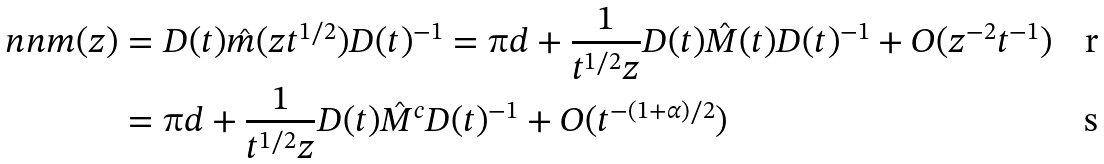Convert formula to latex. <formula><loc_0><loc_0><loc_500><loc_500>\ n n m ( z ) & = D ( t ) \hat { m } ( z t ^ { 1 / 2 } ) D ( t ) ^ { - 1 } = \i d + \frac { 1 } { t ^ { 1 / 2 } z } D ( t ) \hat { M } ( t ) D ( t ) ^ { - 1 } + O ( z ^ { - 2 } t ^ { - 1 } ) \\ & = \i d + \frac { 1 } { t ^ { 1 / 2 } z } D ( t ) \hat { M } ^ { c } D ( t ) ^ { - 1 } + O ( t ^ { - ( 1 + \alpha ) / 2 } )</formula> 